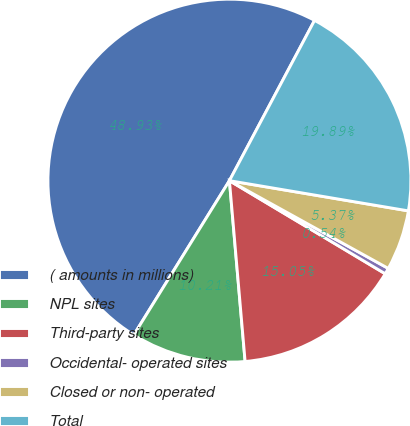Convert chart. <chart><loc_0><loc_0><loc_500><loc_500><pie_chart><fcel>( amounts in millions)<fcel>NPL sites<fcel>Third-party sites<fcel>Occidental- operated sites<fcel>Closed or non- operated<fcel>Total<nl><fcel>48.93%<fcel>10.21%<fcel>15.05%<fcel>0.54%<fcel>5.37%<fcel>19.89%<nl></chart> 